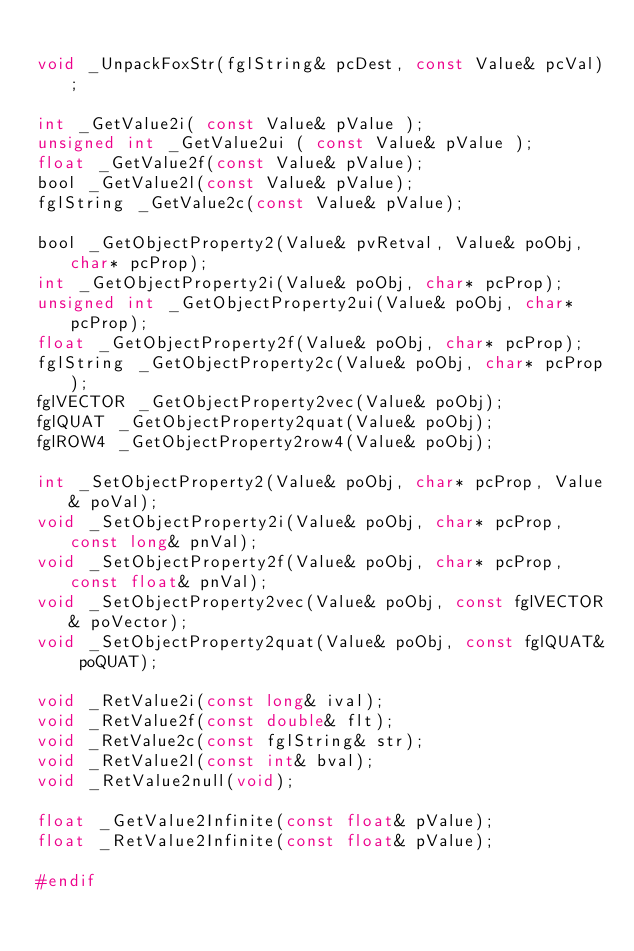<code> <loc_0><loc_0><loc_500><loc_500><_C_>
void _UnpackFoxStr(fglString& pcDest, const Value& pcVal);

int _GetValue2i( const Value& pValue );
unsigned int _GetValue2ui ( const Value& pValue );
float _GetValue2f(const Value& pValue);
bool _GetValue2l(const Value& pValue);
fglString _GetValue2c(const Value& pValue);

bool _GetObjectProperty2(Value& pvRetval, Value& poObj, char* pcProp);
int _GetObjectProperty2i(Value& poObj, char* pcProp);
unsigned int _GetObjectProperty2ui(Value& poObj, char* pcProp);
float _GetObjectProperty2f(Value& poObj, char* pcProp);
fglString _GetObjectProperty2c(Value& poObj, char* pcProp);
fglVECTOR _GetObjectProperty2vec(Value& poObj);
fglQUAT _GetObjectProperty2quat(Value& poObj);
fglROW4 _GetObjectProperty2row4(Value& poObj);

int _SetObjectProperty2(Value& poObj, char* pcProp, Value& poVal);
void _SetObjectProperty2i(Value& poObj, char* pcProp, const long& pnVal);
void _SetObjectProperty2f(Value& poObj, char* pcProp, const float& pnVal);
void _SetObjectProperty2vec(Value& poObj, const fglVECTOR& poVector);
void _SetObjectProperty2quat(Value& poObj, const fglQUAT& poQUAT);

void _RetValue2i(const long& ival);
void _RetValue2f(const double& flt);
void _RetValue2c(const fglString& str);
void _RetValue2l(const int& bval);
void _RetValue2null(void);

float _GetValue2Infinite(const float& pValue);
float _RetValue2Infinite(const float& pValue);

#endif
</code> 